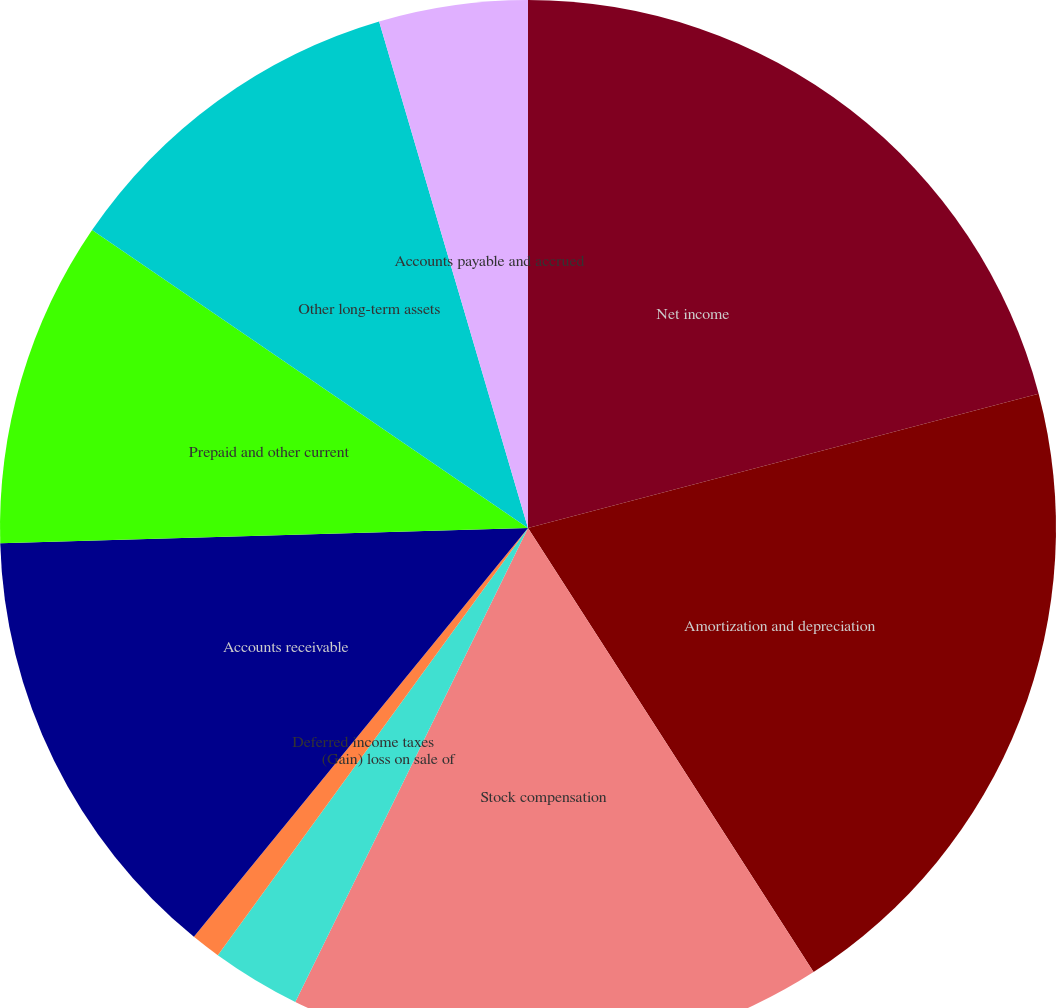Convert chart to OTSL. <chart><loc_0><loc_0><loc_500><loc_500><pie_chart><fcel>Net income<fcel>Amortization and depreciation<fcel>Stock compensation<fcel>Allowance for doubtful<fcel>(Gain) loss on sale of<fcel>Deferred income taxes<fcel>Accounts receivable<fcel>Prepaid and other current<fcel>Other long-term assets<fcel>Accounts payable and accrued<nl><fcel>20.91%<fcel>20.0%<fcel>16.36%<fcel>0.0%<fcel>2.73%<fcel>0.91%<fcel>13.64%<fcel>10.0%<fcel>10.91%<fcel>4.55%<nl></chart> 